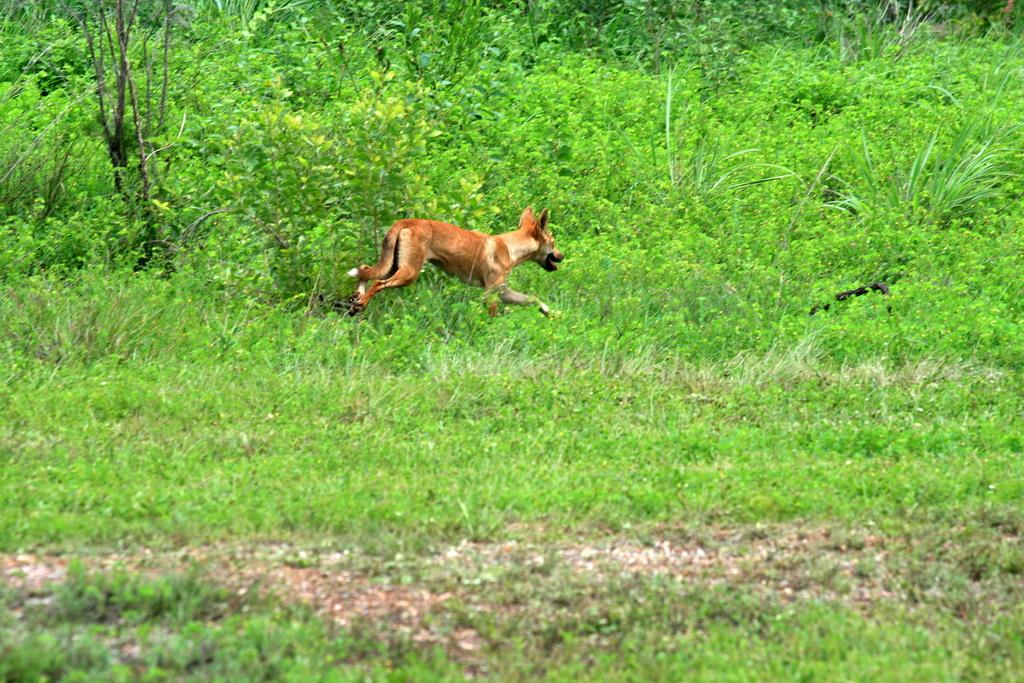What type of vegetation is visible in the image? There is grass in the image. What other type of vegetation can be seen in the image? There are plants in the image. What is the color of the dog in the center of the image? There is a cream-colored dog in the center of the image. How many fifths of the image is covered by the dog? The concept of "fifths" does not apply to the image, as it is not a mathematical division of the image. What type of trousers is the dog wearing in the image? Dogs do not wear trousers, so this question is not applicable to the image. 